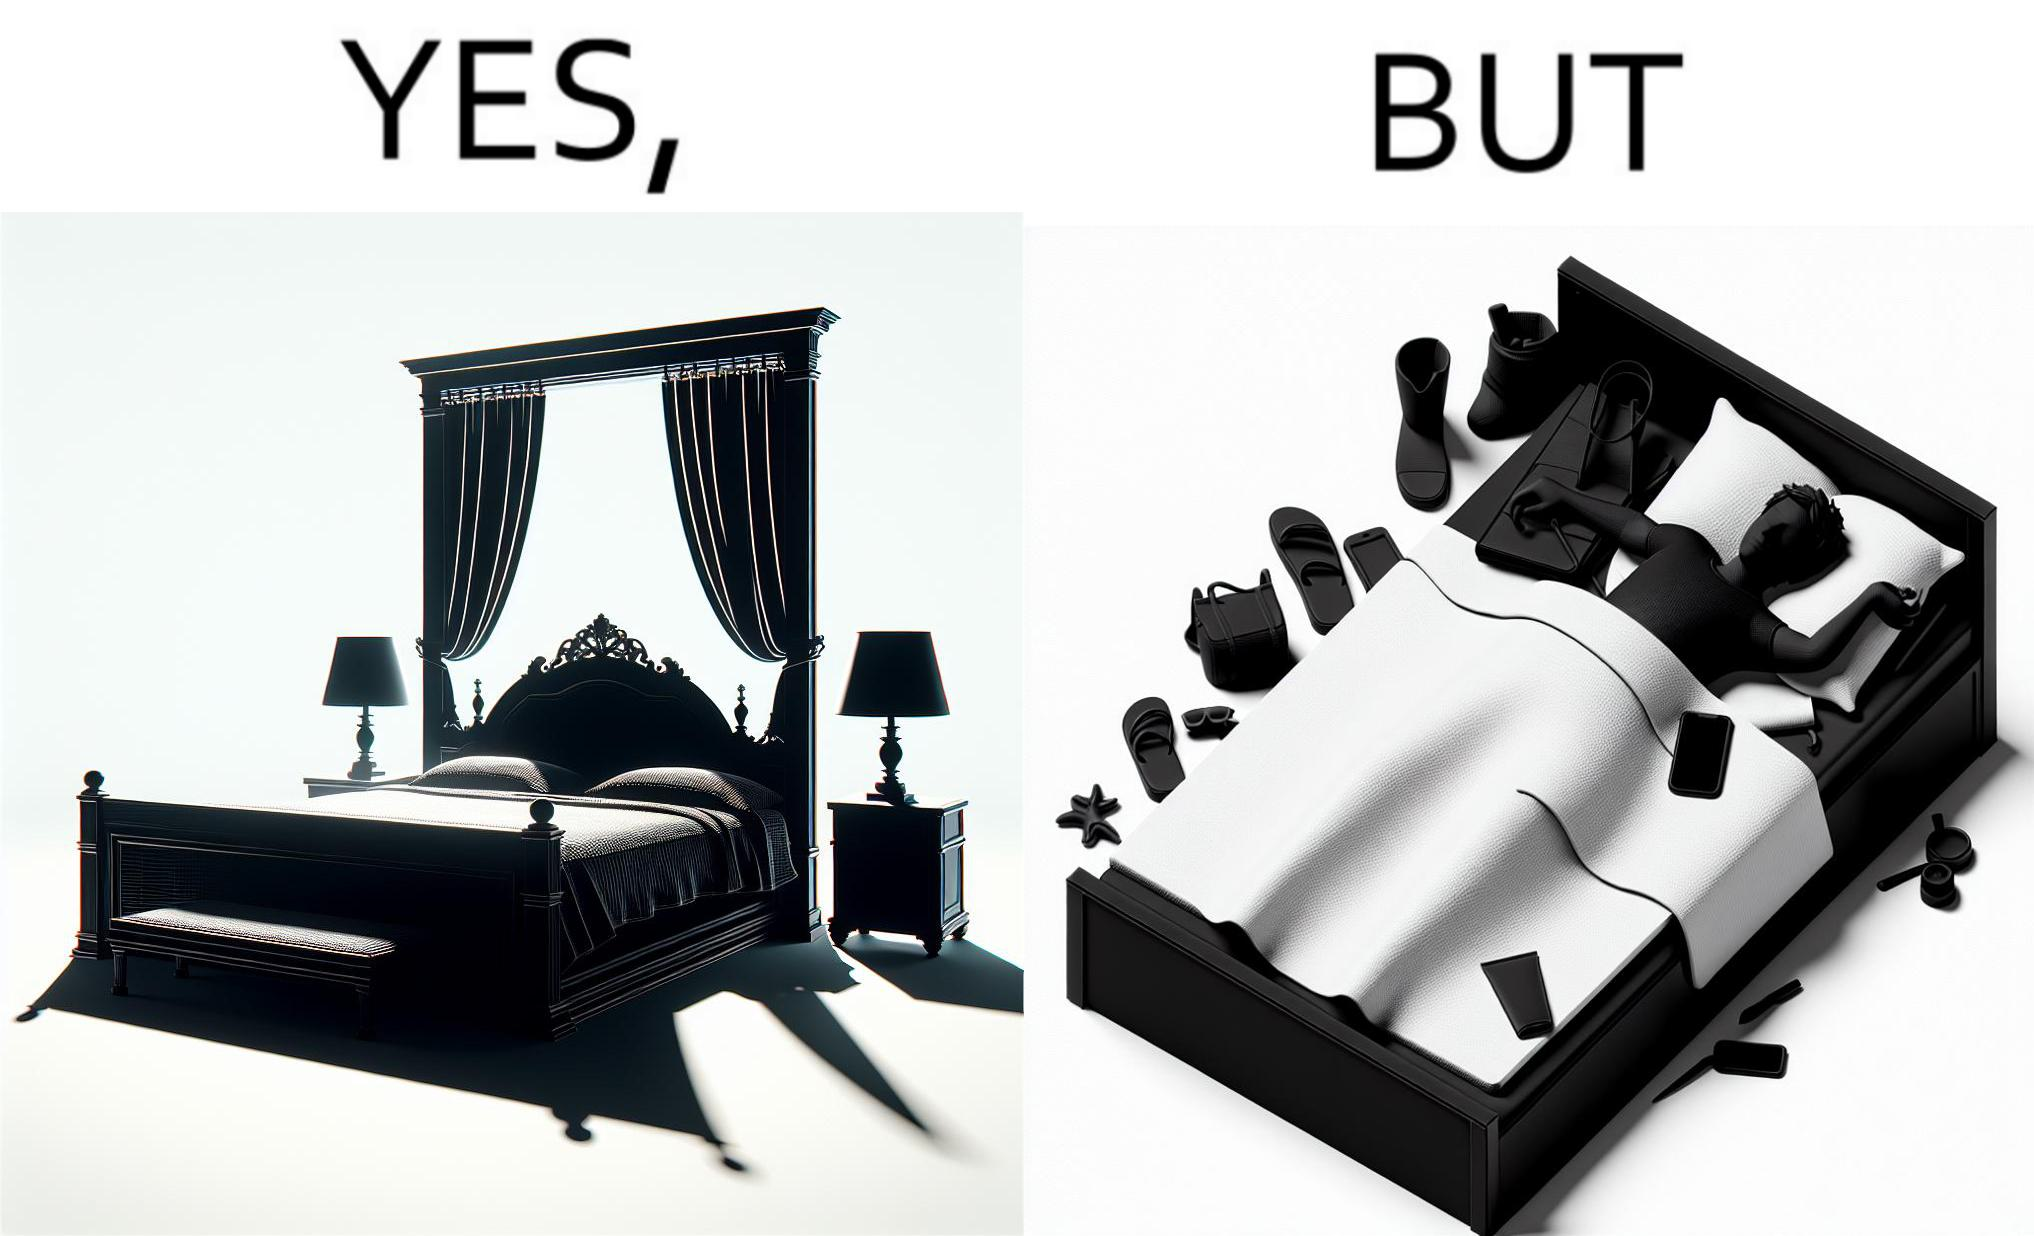Describe what you see in this image. Although the person has purchased a king size bed, but only less than half of the space is used by the person for sleeping. 